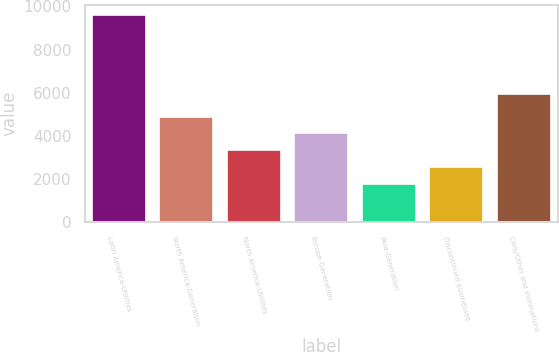Convert chart. <chart><loc_0><loc_0><loc_500><loc_500><bar_chart><fcel>Latin America-Utilities<fcel>North America-Generation<fcel>North America-Utilities<fcel>Europe-Generation<fcel>Asia-Generation<fcel>Discontinued businesses<fcel>Corp/Other and eliminations<nl><fcel>9609<fcel>4900.8<fcel>3331.4<fcel>4116.1<fcel>1762<fcel>2546.7<fcel>5948<nl></chart> 